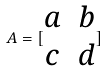Convert formula to latex. <formula><loc_0><loc_0><loc_500><loc_500>A = [ \begin{matrix} a & b \\ c & d \end{matrix} ]</formula> 